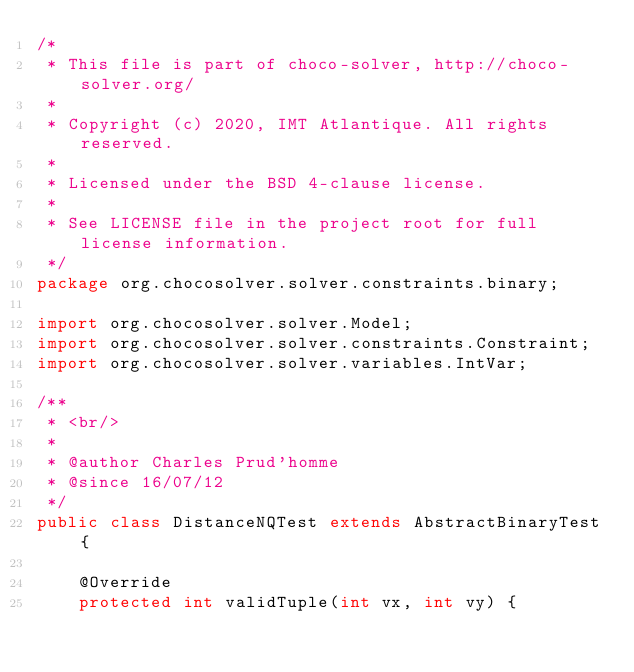<code> <loc_0><loc_0><loc_500><loc_500><_Java_>/*
 * This file is part of choco-solver, http://choco-solver.org/
 *
 * Copyright (c) 2020, IMT Atlantique. All rights reserved.
 *
 * Licensed under the BSD 4-clause license.
 *
 * See LICENSE file in the project root for full license information.
 */
package org.chocosolver.solver.constraints.binary;

import org.chocosolver.solver.Model;
import org.chocosolver.solver.constraints.Constraint;
import org.chocosolver.solver.variables.IntVar;

/**
 * <br/>
 *
 * @author Charles Prud'homme
 * @since 16/07/12
 */
public class DistanceNQTest extends AbstractBinaryTest {

    @Override
    protected int validTuple(int vx, int vy) {</code> 